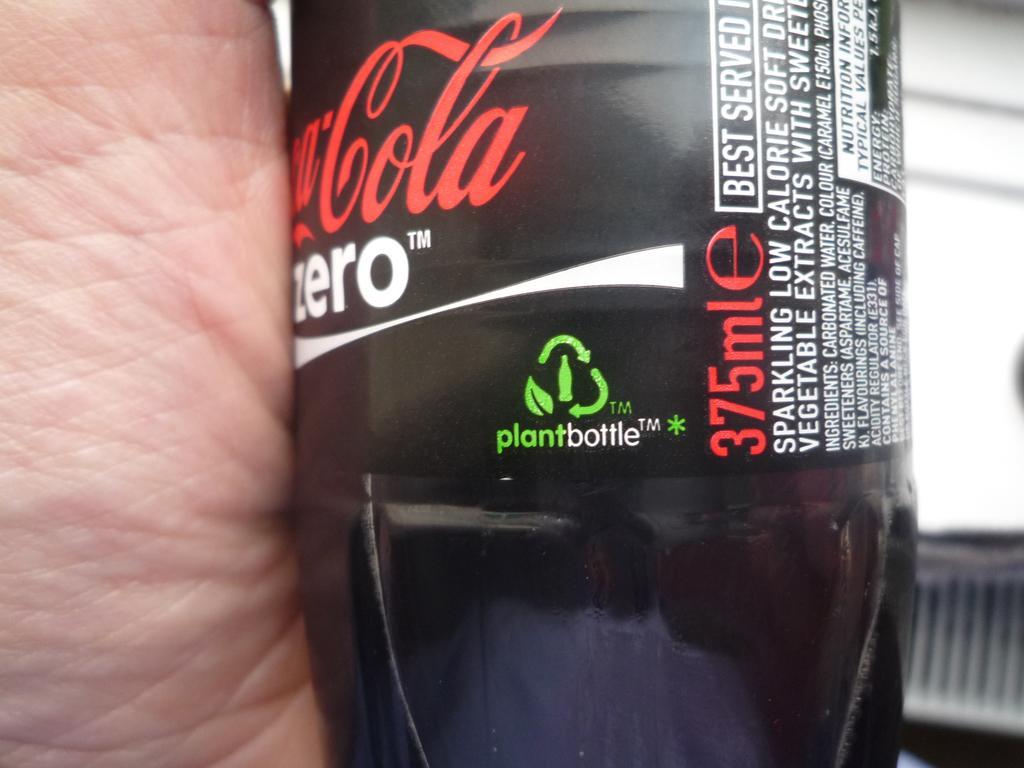Please provide a concise description of this image. Here we can see that a black bottle and something written on it. 